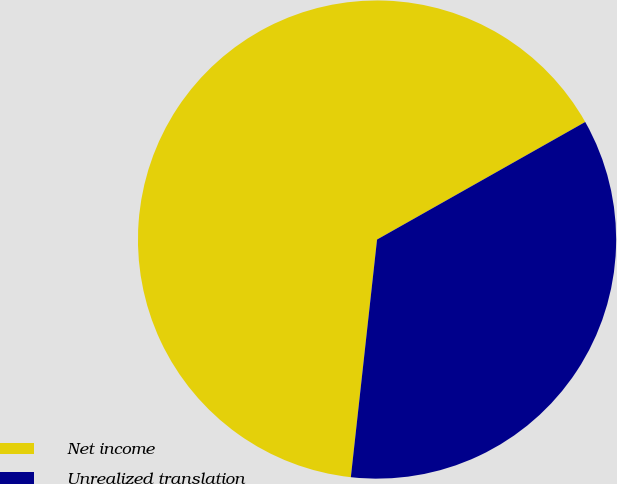<chart> <loc_0><loc_0><loc_500><loc_500><pie_chart><fcel>Net income<fcel>Unrealized translation<nl><fcel>65.07%<fcel>34.93%<nl></chart> 